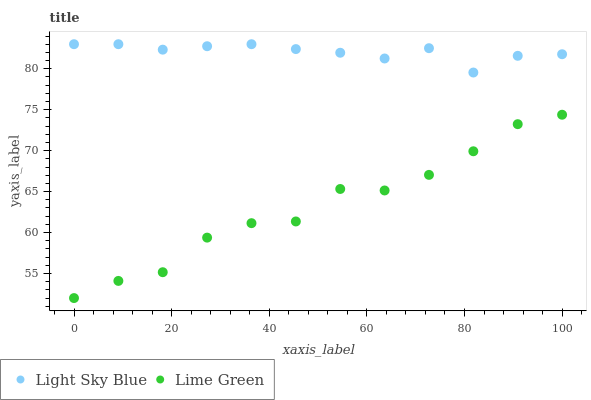Does Lime Green have the minimum area under the curve?
Answer yes or no. Yes. Does Light Sky Blue have the maximum area under the curve?
Answer yes or no. Yes. Does Lime Green have the maximum area under the curve?
Answer yes or no. No. Is Light Sky Blue the smoothest?
Answer yes or no. Yes. Is Lime Green the roughest?
Answer yes or no. Yes. Is Lime Green the smoothest?
Answer yes or no. No. Does Lime Green have the lowest value?
Answer yes or no. Yes. Does Light Sky Blue have the highest value?
Answer yes or no. Yes. Does Lime Green have the highest value?
Answer yes or no. No. Is Lime Green less than Light Sky Blue?
Answer yes or no. Yes. Is Light Sky Blue greater than Lime Green?
Answer yes or no. Yes. Does Lime Green intersect Light Sky Blue?
Answer yes or no. No. 